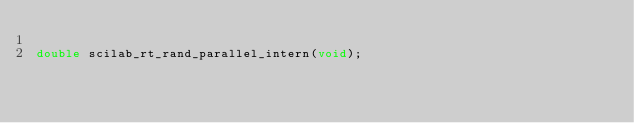<code> <loc_0><loc_0><loc_500><loc_500><_C_>
double scilab_rt_rand_parallel_intern(void);

</code> 